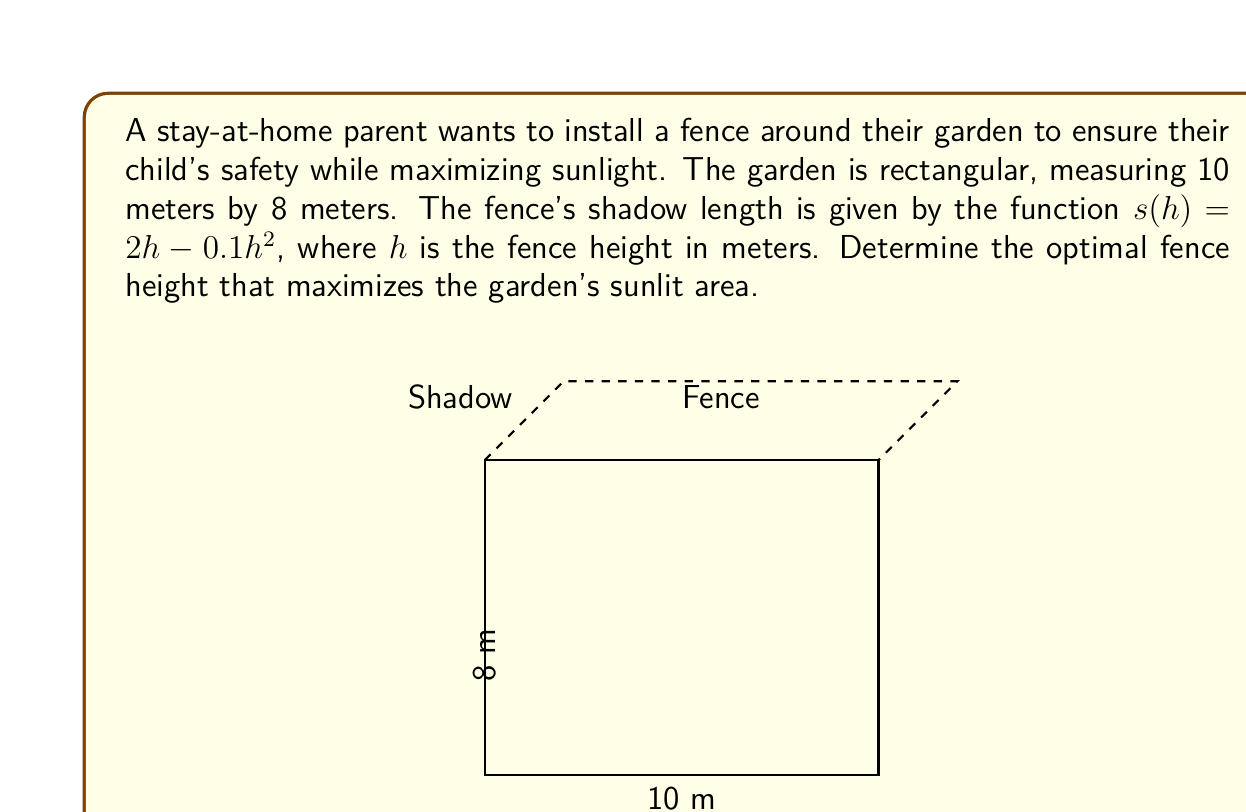Teach me how to tackle this problem. Let's approach this step-by-step:

1) The total area of the garden is $A = 10 \times 8 = 80$ square meters.

2) The shadow area can be calculated by multiplying the shadow length by the perimeter of the garden:
   $A_{shadow}(h) = s(h) \times 2(10 + 8) = 36s(h) = 36(2h - 0.1h^2)$

3) The sunlit area is the total area minus the shadow area:
   $A_{sunlit}(h) = 80 - 36(2h - 0.1h^2) = 80 - 72h + 3.6h^2$

4) To find the maximum sunlit area, we need to find the critical points of this function. We do this by taking the derivative and setting it equal to zero:
   $$\frac{d}{dh}A_{sunlit}(h) = -72 + 7.2h = 0$$

5) Solving this equation:
   $7.2h = 72$
   $h = 10$

6) To confirm this is a maximum, we can check the second derivative:
   $$\frac{d^2}{dh^2}A_{sunlit}(h) = 7.2 > 0$$
   This confirms that $h = 10$ gives a local maximum.

7) However, we need to consider practical constraints. A 10-meter fence is unreasonably tall for a home garden. Let's assume a maximum practical height of 2 meters.

8) Evaluating $A_{sunlit}(h)$ at $h = 2$:
   $A_{sunlit}(2) = 80 - 72(2) + 3.6(2^2) = 80 - 144 + 14.4 = -49.6$

   This negative value indicates that a 2-meter fence would cast a shadow over the entire garden.

9) We need to find a balance between safety and sunlight. A common recommendation for child safety is a fence height of 1.2 meters (4 feet).

10) Evaluating $A_{sunlit}(h)$ at $h = 1.2$:
    $A_{sunlit}(1.2) = 80 - 72(1.2) + 3.6(1.2^2) = 80 - 86.4 + 5.184 = -1.216$

    This is still negative, but much closer to zero, meaning most of the garden would receive sunlight.

Therefore, considering both safety and sunlight, a fence height of 1.2 meters is recommended.
Answer: 1.2 meters 